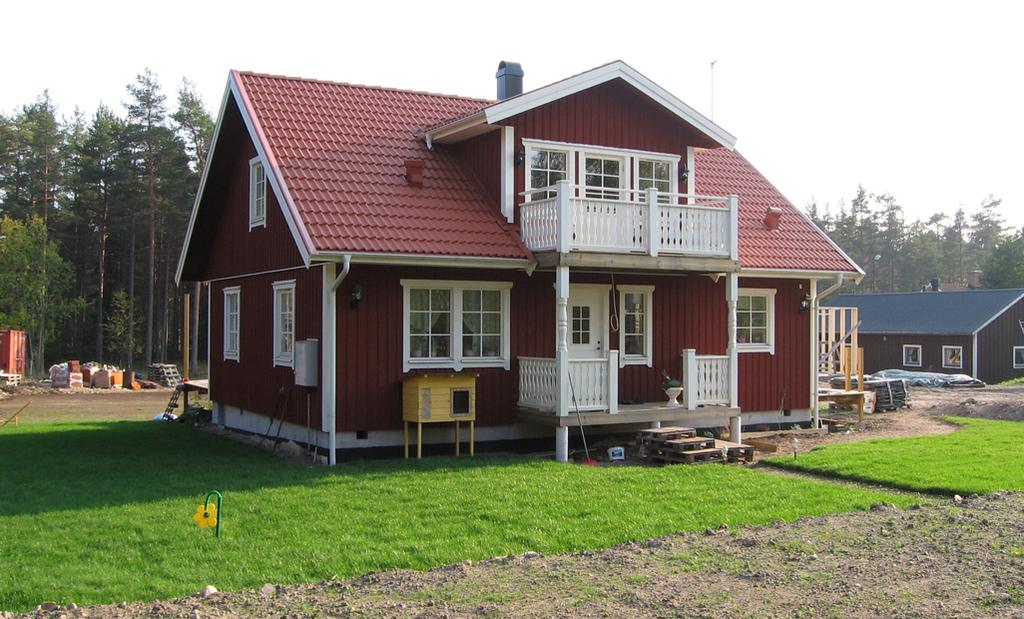What type of vegetation is present in the image? There is grass in the image. What structures can be seen in the image? There are houses in the image. What can be seen in the background of the image? There are trees and the sky visible in the background of the image. What type of muscle is visible in the image? There is no muscle visible in the image; it features grass, houses, trees, and the sky. What observation can be made about the clouds in the image? There are no clouds mentioned in the image, so no observation about clouds can be made. 